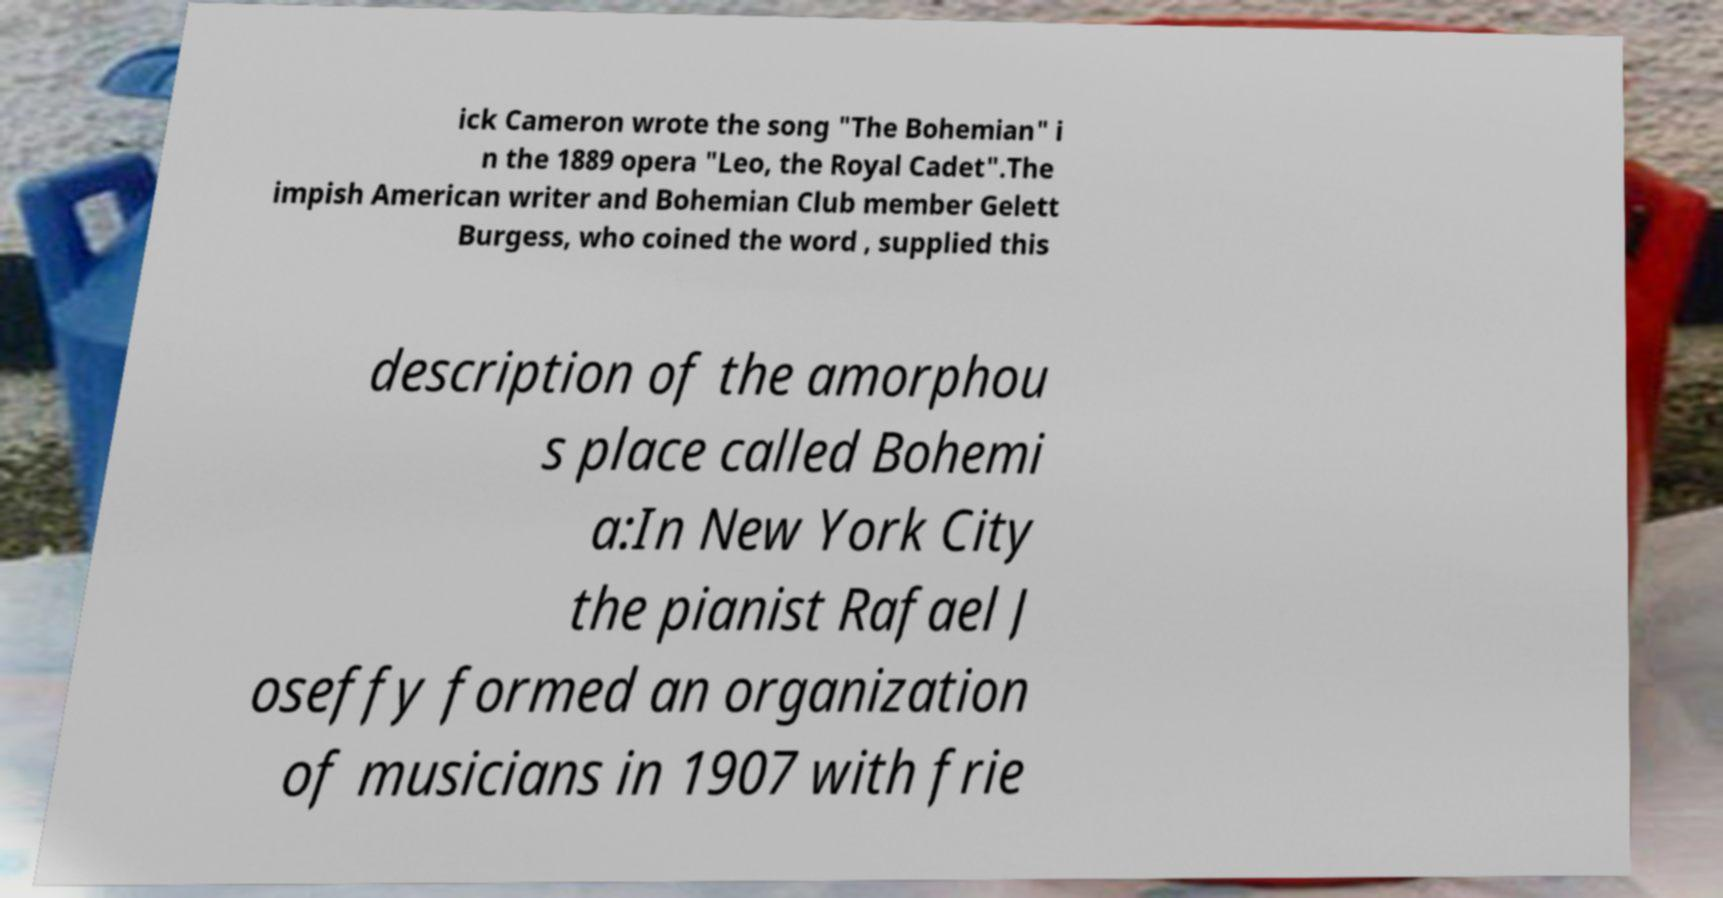Could you assist in decoding the text presented in this image and type it out clearly? ick Cameron wrote the song "The Bohemian" i n the 1889 opera "Leo, the Royal Cadet".The impish American writer and Bohemian Club member Gelett Burgess, who coined the word , supplied this description of the amorphou s place called Bohemi a:In New York City the pianist Rafael J oseffy formed an organization of musicians in 1907 with frie 